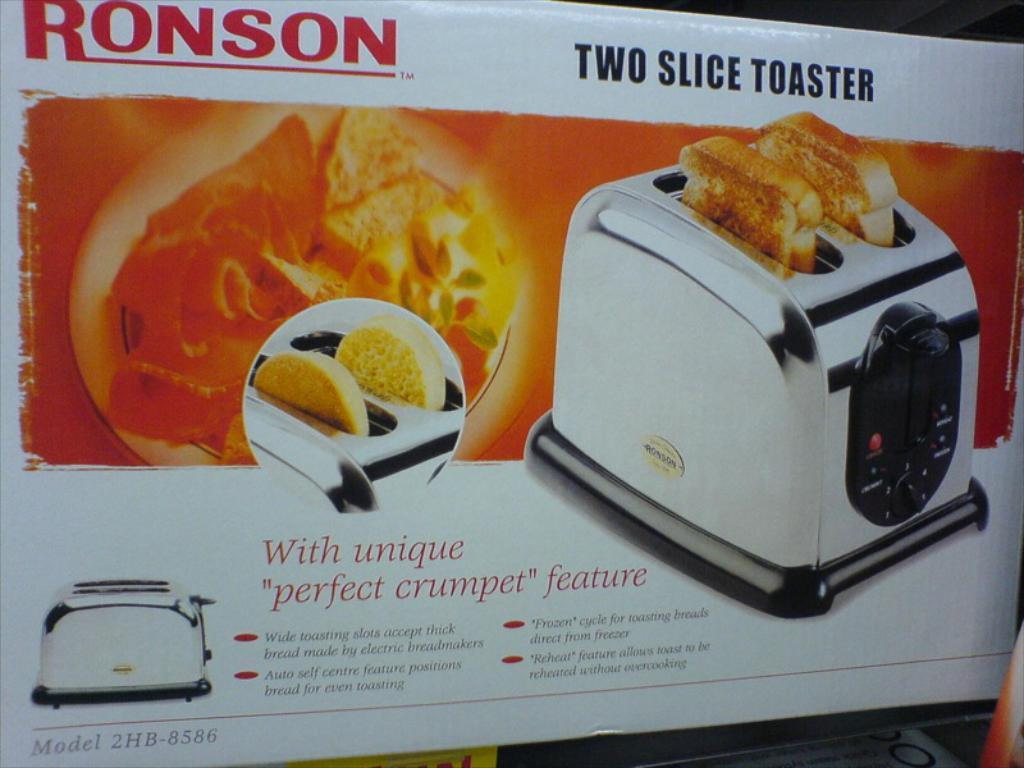<image>
Create a compact narrative representing the image presented. A box for the Ronson Two Slice Toaster has a picture of the toaster. 